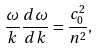<formula> <loc_0><loc_0><loc_500><loc_500>\frac { \omega } { k } \frac { d \omega } { d k } = \frac { c _ { 0 } ^ { 2 } } { n ^ { 2 } } ,</formula> 